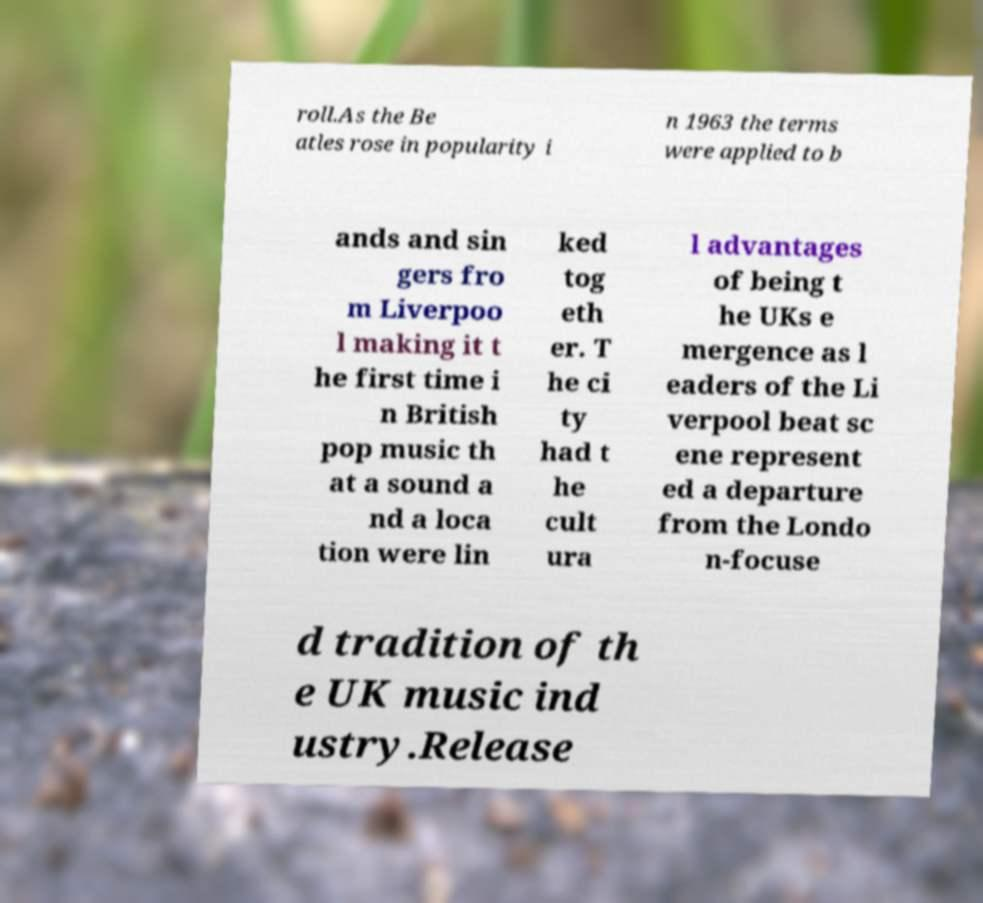Can you read and provide the text displayed in the image?This photo seems to have some interesting text. Can you extract and type it out for me? roll.As the Be atles rose in popularity i n 1963 the terms were applied to b ands and sin gers fro m Liverpoo l making it t he first time i n British pop music th at a sound a nd a loca tion were lin ked tog eth er. T he ci ty had t he cult ura l advantages of being t he UKs e mergence as l eaders of the Li verpool beat sc ene represent ed a departure from the Londo n-focuse d tradition of th e UK music ind ustry.Release 